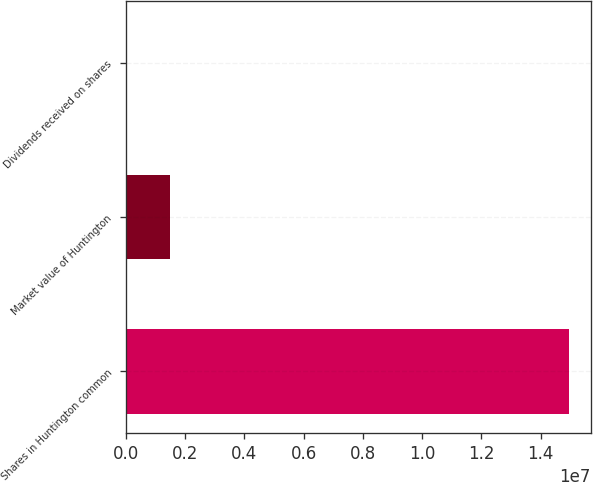<chart> <loc_0><loc_0><loc_500><loc_500><bar_chart><fcel>Shares in Huntington common<fcel>Market value of Huntington<fcel>Dividends received on shares<nl><fcel>1.49455e+07<fcel>1.49455e+06<fcel>0.6<nl></chart> 